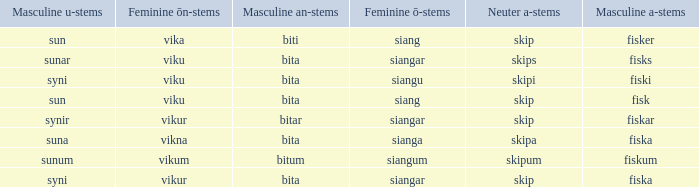What is the u form of the word with a neuter form of skip and a masculine a-ending of fisker? Sun. 